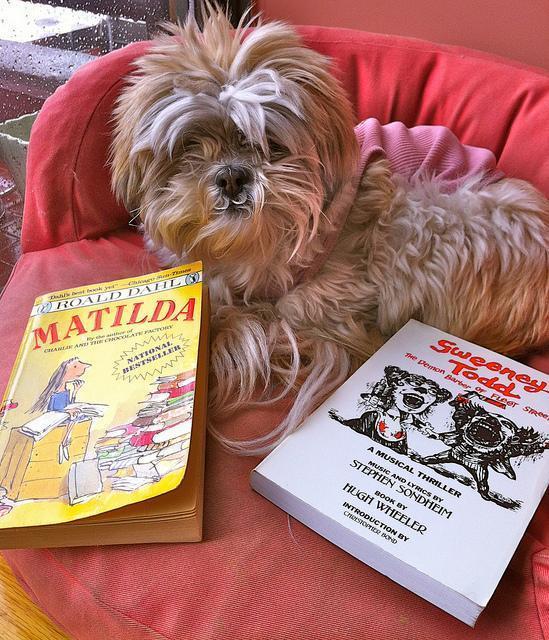How many books do you see?
Give a very brief answer. 2. How many books are there?
Give a very brief answer. 2. How many people have black shirts on?
Give a very brief answer. 0. 